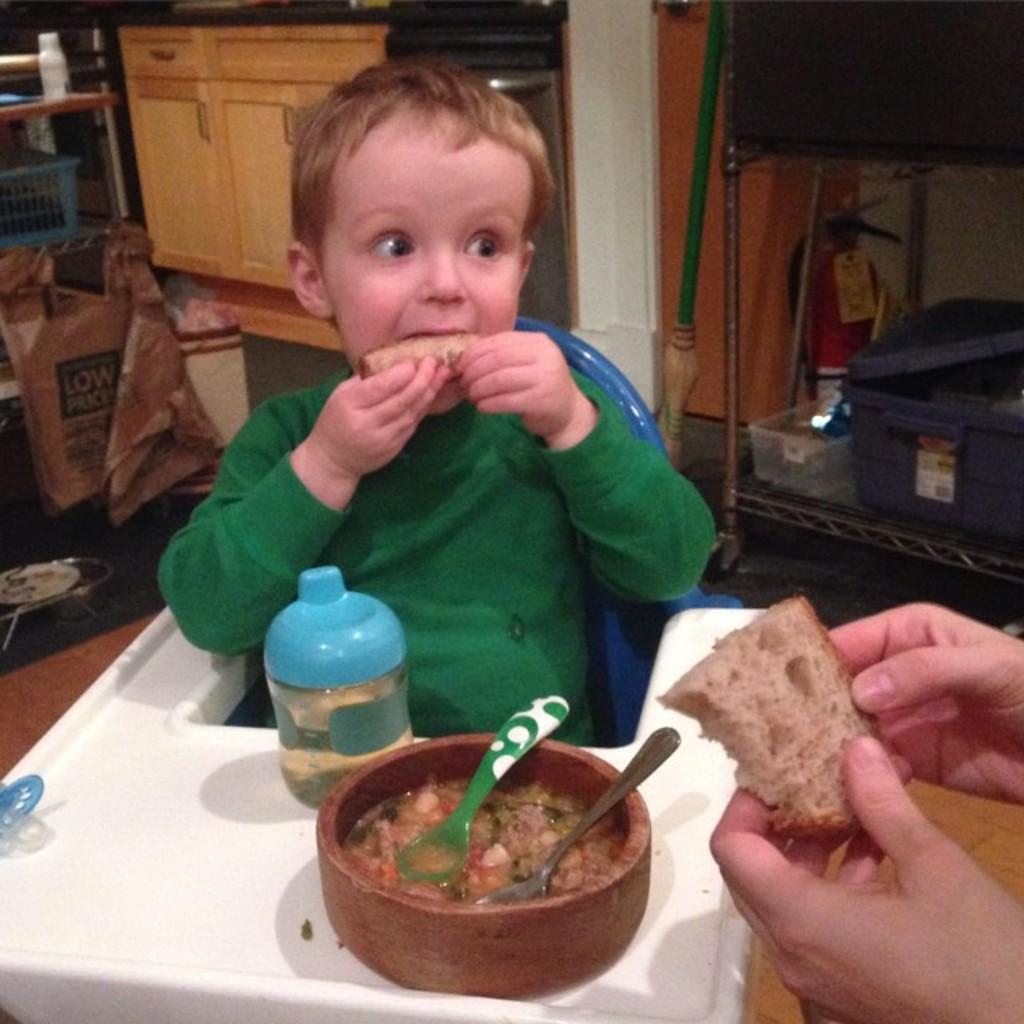In one or two sentences, can you explain what this image depicts? In this image there is a kid wearing green color shirt having some bread and in front of him there is some food item and baby sipper. 